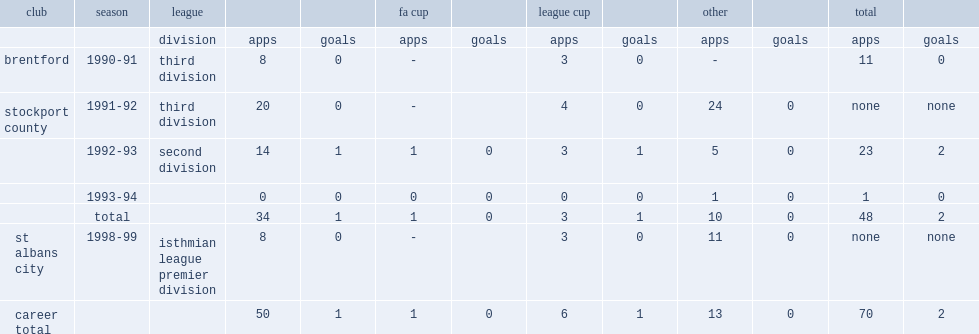Which club did carstairs play for in 1998-99? St albans city. 